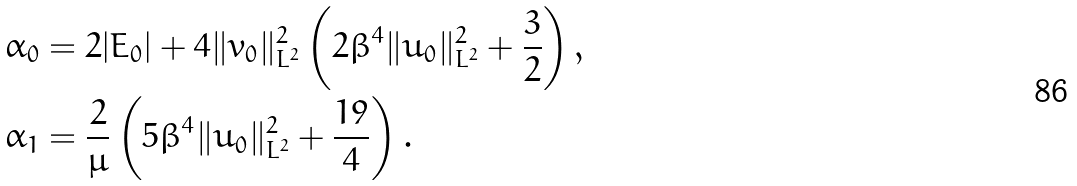<formula> <loc_0><loc_0><loc_500><loc_500>& \alpha _ { 0 } = 2 | E _ { 0 } | + 4 \| v _ { 0 } \| ^ { 2 } _ { L ^ { 2 } } \left ( 2 \beta ^ { 4 } \| u _ { 0 } \| ^ { 2 } _ { L ^ { 2 } } + \frac { 3 } { 2 } \right ) , \\ & \alpha _ { 1 } = \frac { 2 } { \mu } \left ( 5 \beta ^ { 4 } \| u _ { 0 } \| _ { L ^ { 2 } } ^ { 2 } + \frac { 1 9 } 4 \right ) .</formula> 